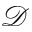<formula> <loc_0><loc_0><loc_500><loc_500>\mathcal { D }</formula> 